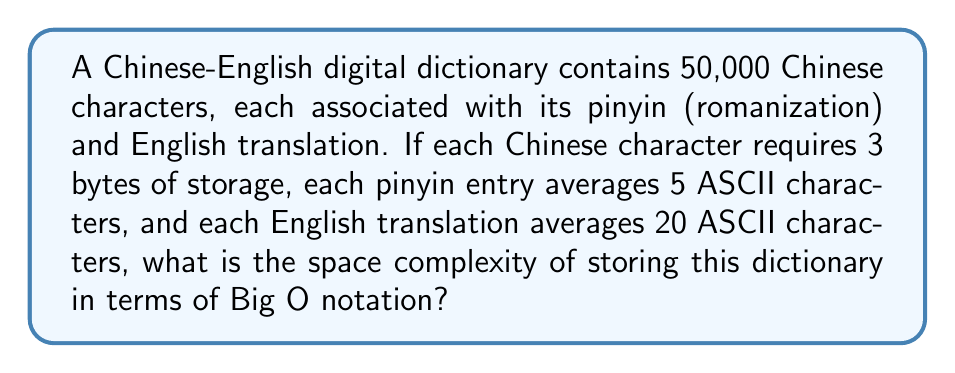Could you help me with this problem? To determine the space complexity, we need to calculate the total storage required and express it in terms of the input size. Let's break it down step by step:

1. Storage for Chinese characters:
   - Each character requires 3 bytes
   - Total bytes for characters = $50,000 \times 3 = 150,000$ bytes

2. Storage for pinyin:
   - Each pinyin entry averages 5 ASCII characters
   - Each ASCII character requires 1 byte
   - Total bytes for pinyin = $50,000 \times 5 = 250,000$ bytes

3. Storage for English translations:
   - Each translation averages 20 ASCII characters
   - Each ASCII character requires 1 byte
   - Total bytes for translations = $50,000 \times 20 = 1,000,000$ bytes

4. Total storage:
   $150,000 + 250,000 + 1,000,000 = 1,400,000$ bytes

Let $n$ be the number of entries in the dictionary (50,000 in this case).

The space required is directly proportional to $n$:
$$\text{Space} = 3n + 5n + 20n = 28n \text{ bytes}$$

In Big O notation, we express this as $O(n)$, as we ignore constant factors.

The space complexity is linear with respect to the number of entries in the dictionary.
Answer: $O(n)$ 